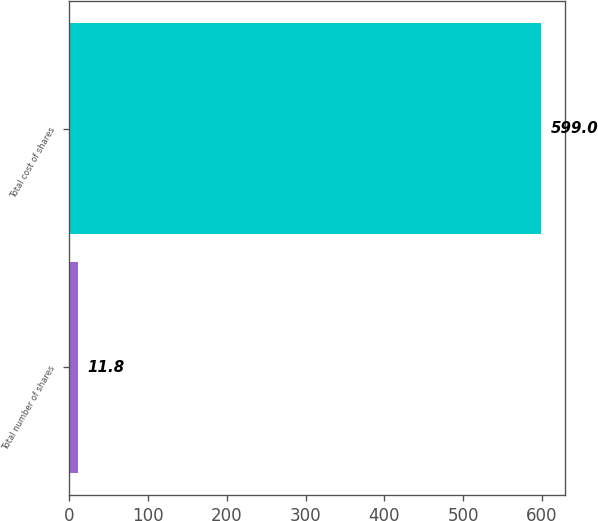<chart> <loc_0><loc_0><loc_500><loc_500><bar_chart><fcel>Total number of shares<fcel>Total cost of shares<nl><fcel>11.8<fcel>599<nl></chart> 